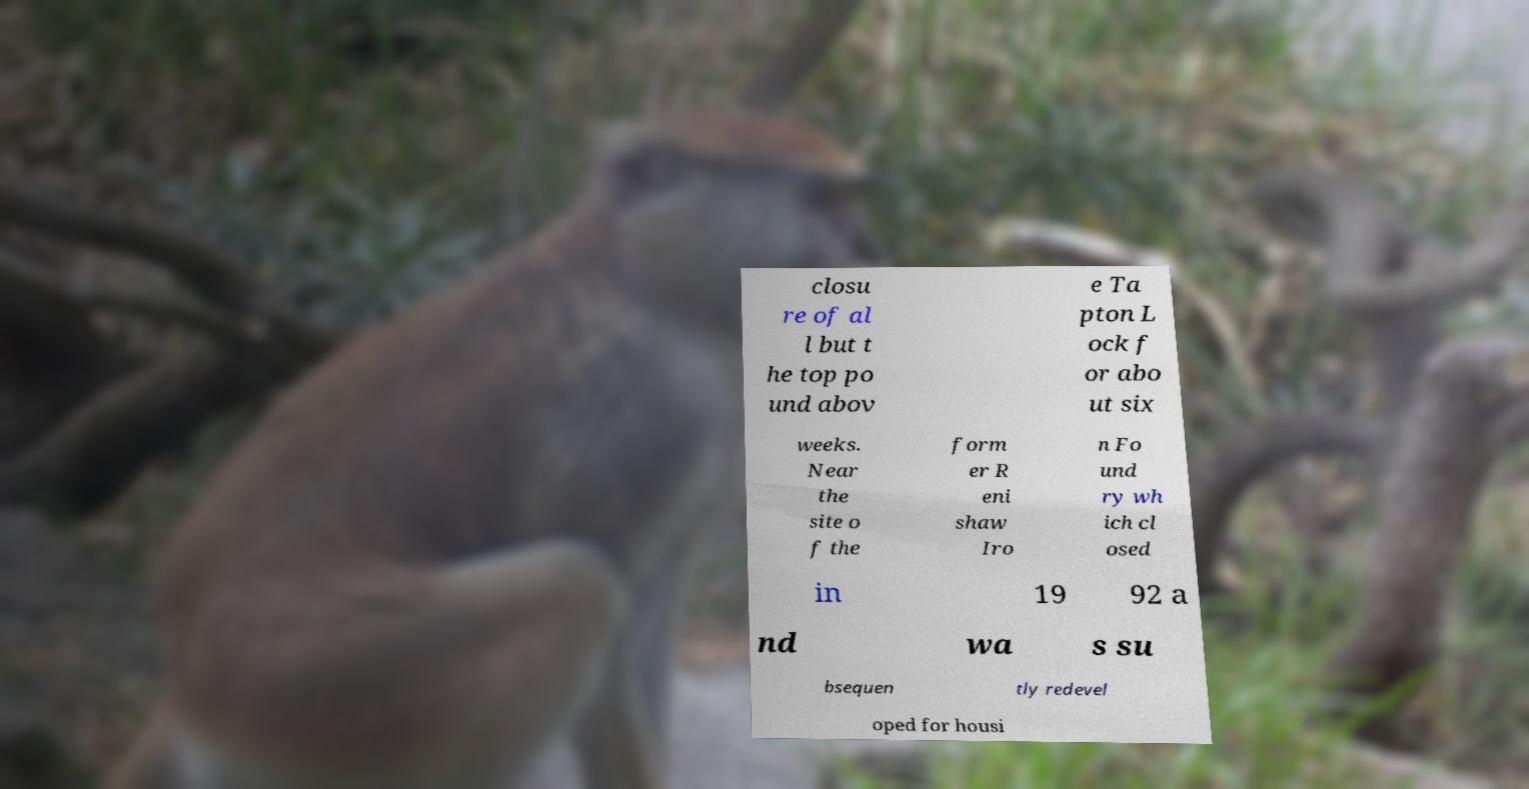Could you assist in decoding the text presented in this image and type it out clearly? closu re of al l but t he top po und abov e Ta pton L ock f or abo ut six weeks. Near the site o f the form er R eni shaw Iro n Fo und ry wh ich cl osed in 19 92 a nd wa s su bsequen tly redevel oped for housi 